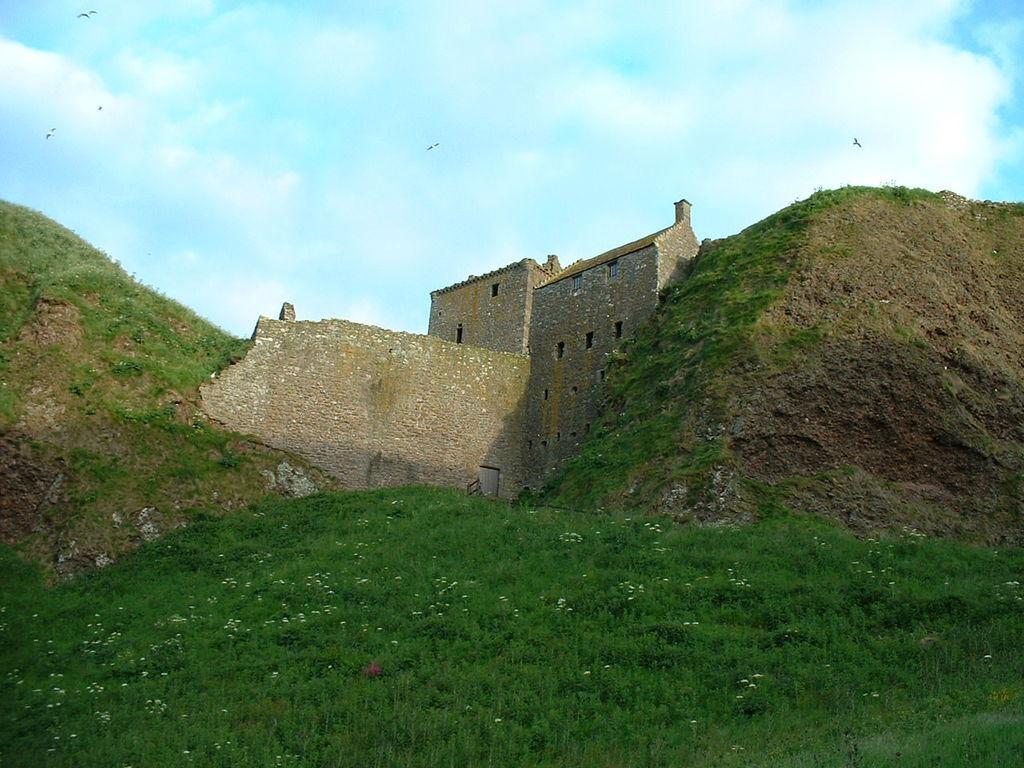Please provide a concise description of this image. At the bottom of this image, there is grass on the ground. In the background, there are mountains, a wall, buildings and there are clouds in the sky. 